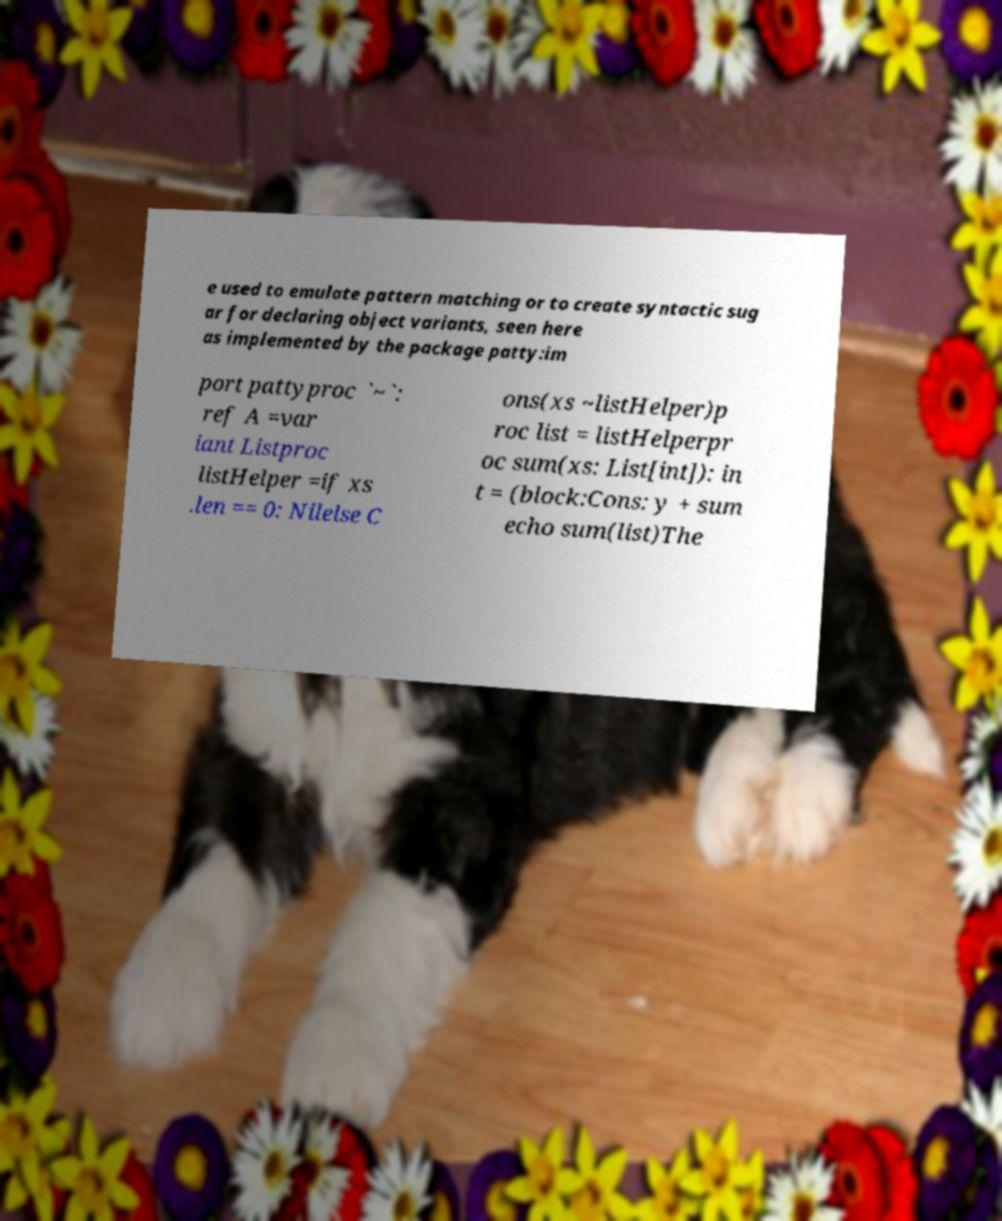For documentation purposes, I need the text within this image transcribed. Could you provide that? e used to emulate pattern matching or to create syntactic sug ar for declaring object variants, seen here as implemented by the package patty:im port pattyproc `~`: ref A =var iant Listproc listHelper =if xs .len == 0: Nilelse C ons(xs ~listHelper)p roc list = listHelperpr oc sum(xs: List[int]): in t = (block:Cons: y + sum echo sum(list)The 